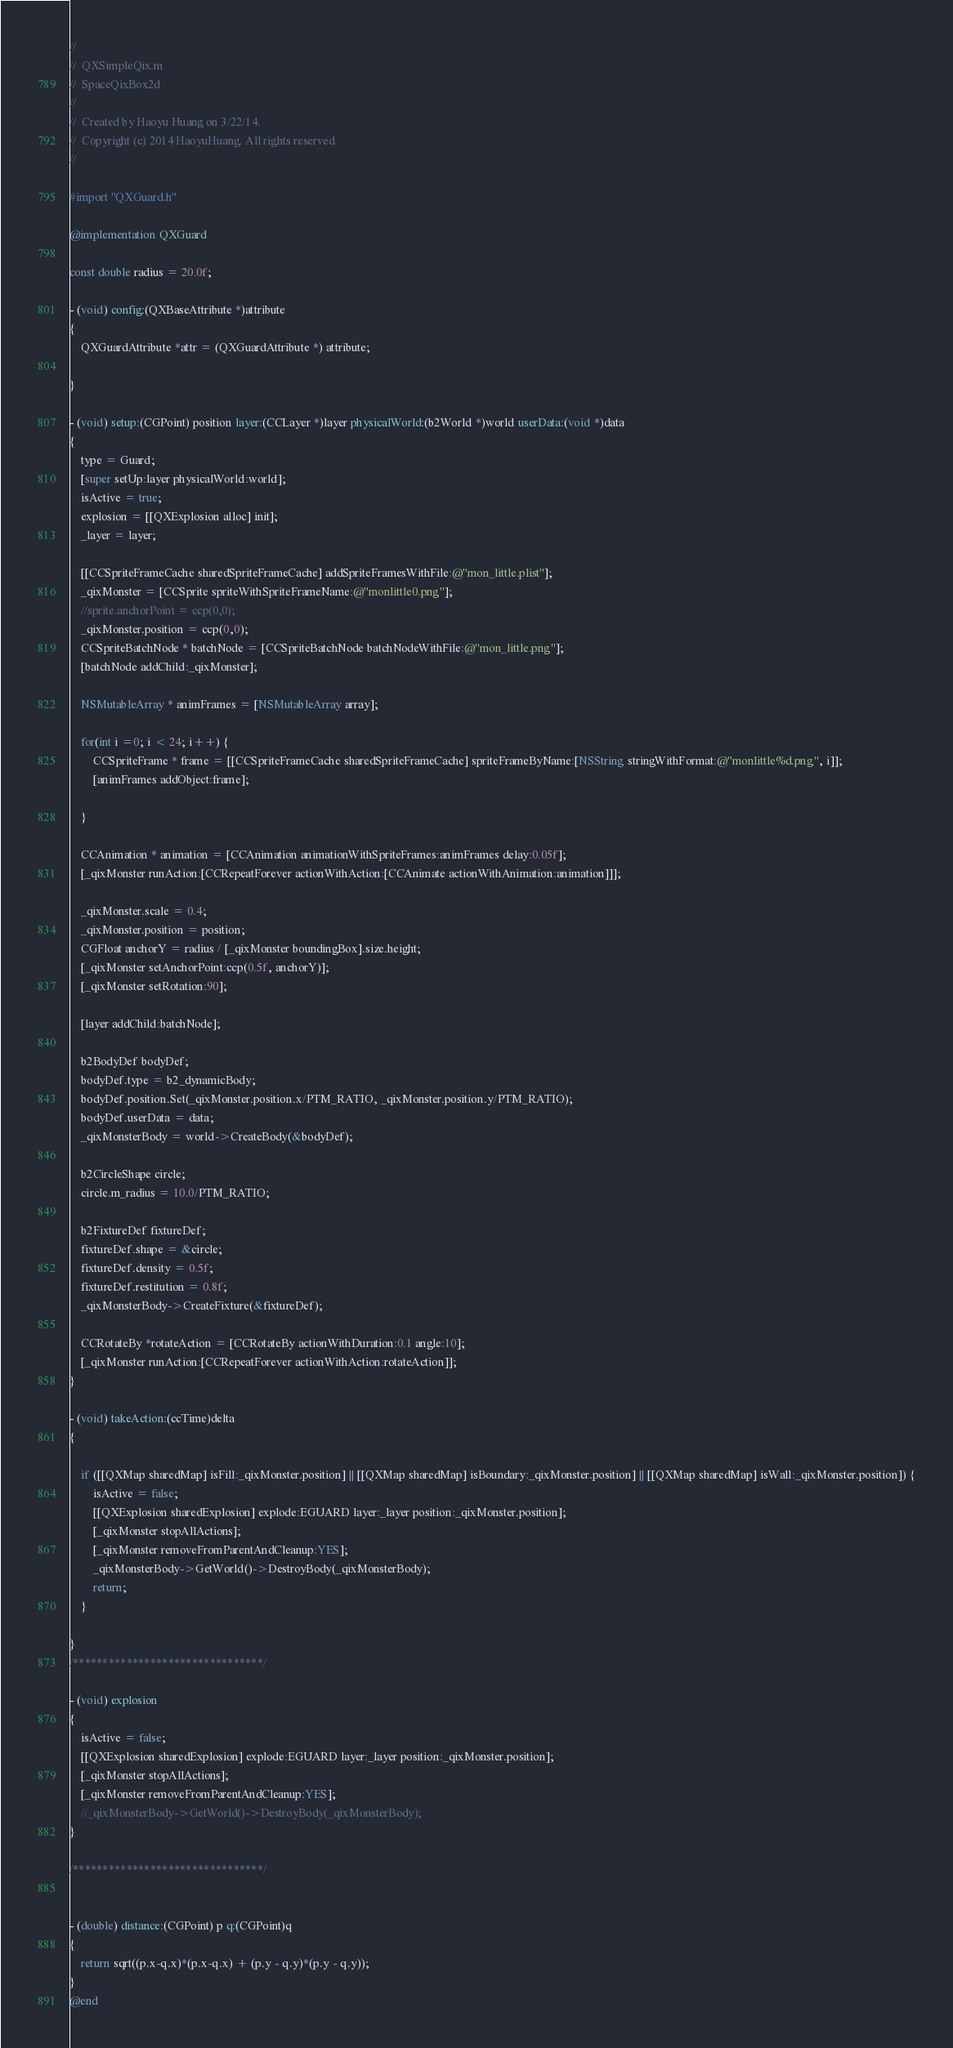Convert code to text. <code><loc_0><loc_0><loc_500><loc_500><_ObjectiveC_>//
//  QXSimpleQix.m
//  SpaceQixBox2d
//
//  Created by Haoyu Huang on 3/22/14.
//  Copyright (c) 2014 HaoyuHuang. All rights reserved.
//

#import "QXGuard.h"

@implementation QXGuard

const double radius = 20.0f;

- (void) config:(QXBaseAttribute *)attribute
{
    QXGuardAttribute *attr = (QXGuardAttribute *) attribute;
    
}

- (void) setup:(CGPoint) position layer:(CCLayer *)layer physicalWorld:(b2World *)world userData:(void *)data
{
    type = Guard;
    [super setUp:layer physicalWorld:world];
    isActive = true;
    explosion = [[QXExplosion alloc] init];
    _layer = layer;
    
    [[CCSpriteFrameCache sharedSpriteFrameCache] addSpriteFramesWithFile:@"mon_little.plist"];
    _qixMonster = [CCSprite spriteWithSpriteFrameName:@"monlittle0.png"];
    //sprite.anchorPoint = ccp(0,0);
    _qixMonster.position = ccp(0,0);
    CCSpriteBatchNode * batchNode = [CCSpriteBatchNode batchNodeWithFile:@"mon_little.png"];
    [batchNode addChild:_qixMonster];
    
    NSMutableArray * animFrames = [NSMutableArray array];
    
    for(int i =0; i < 24; i++) {
        CCSpriteFrame * frame = [[CCSpriteFrameCache sharedSpriteFrameCache] spriteFrameByName:[NSString stringWithFormat:@"monlittle%d.png", i]];
        [animFrames addObject:frame];
        
    }
    
    CCAnimation * animation = [CCAnimation animationWithSpriteFrames:animFrames delay:0.05f];
    [_qixMonster runAction:[CCRepeatForever actionWithAction:[CCAnimate actionWithAnimation:animation]]];
    
    _qixMonster.scale = 0.4;
    _qixMonster.position = position;
    CGFloat anchorY = radius / [_qixMonster boundingBox].size.height;
    [_qixMonster setAnchorPoint:ccp(0.5f, anchorY)];
    [_qixMonster setRotation:90];

    [layer addChild:batchNode];
    
    b2BodyDef bodyDef;
    bodyDef.type = b2_dynamicBody;
    bodyDef.position.Set(_qixMonster.position.x/PTM_RATIO, _qixMonster.position.y/PTM_RATIO);
    bodyDef.userData = data;
    _qixMonsterBody = world->CreateBody(&bodyDef);
    
    b2CircleShape circle;
    circle.m_radius = 10.0/PTM_RATIO;
    
    b2FixtureDef fixtureDef;
    fixtureDef.shape = &circle;
    fixtureDef.density = 0.5f;
    fixtureDef.restitution = 0.8f;
    _qixMonsterBody->CreateFixture(&fixtureDef);
    
    CCRotateBy *rotateAction = [CCRotateBy actionWithDuration:0.1 angle:10];
    [_qixMonster runAction:[CCRepeatForever actionWithAction:rotateAction]];
}

- (void) takeAction:(ccTime)delta
{
    
    if ([[QXMap sharedMap] isFill:_qixMonster.position] || [[QXMap sharedMap] isBoundary:_qixMonster.position] || [[QXMap sharedMap] isWall:_qixMonster.position]) {
        isActive = false;
        [[QXExplosion sharedExplosion] explode:EGUARD layer:_layer position:_qixMonster.position];
        [_qixMonster stopAllActions];
        [_qixMonster removeFromParentAndCleanup:YES];
        _qixMonsterBody->GetWorld()->DestroyBody(_qixMonsterBody);
        return;
    }
    
}
/********************************/

- (void) explosion
{
    isActive = false;
    [[QXExplosion sharedExplosion] explode:EGUARD layer:_layer position:_qixMonster.position];
    [_qixMonster stopAllActions];
    [_qixMonster removeFromParentAndCleanup:YES];
    //_qixMonsterBody->GetWorld()->DestroyBody(_qixMonsterBody);
}

/********************************/


- (double) distance:(CGPoint) p q:(CGPoint)q
{
    return sqrt((p.x-q.x)*(p.x-q.x) + (p.y - q.y)*(p.y - q.y));
}
@end
</code> 